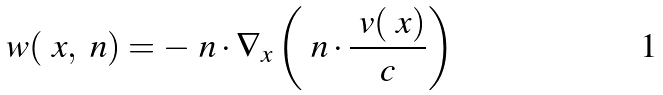Convert formula to latex. <formula><loc_0><loc_0><loc_500><loc_500>w ( \ x , \ n ) = - \ n \cdot \nabla _ { x } \left ( \ n \cdot \frac { \ v ( \ x ) } { c } \right )</formula> 